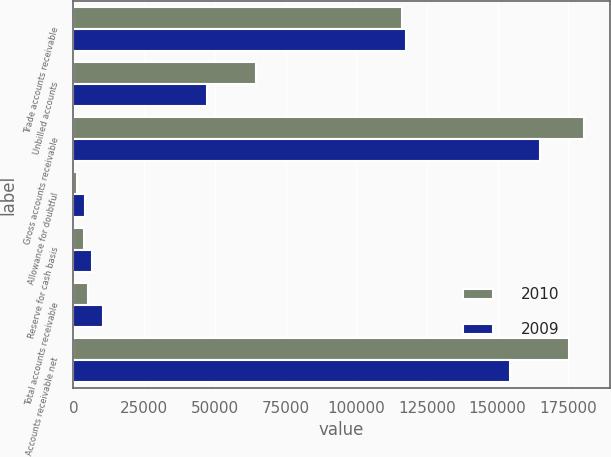Convert chart. <chart><loc_0><loc_0><loc_500><loc_500><stacked_bar_chart><ecel><fcel>Trade accounts receivable<fcel>Unbilled accounts<fcel>Gross accounts receivable<fcel>Allowance for doubtful<fcel>Reserve for cash basis<fcel>Total accounts receivable<fcel>Accounts receivable net<nl><fcel>2010<fcel>116212<fcel>64386<fcel>180598<fcel>1329<fcel>3903<fcel>5232<fcel>175366<nl><fcel>2009<fcel>117449<fcel>47399<fcel>164848<fcel>4137<fcel>6442<fcel>10579<fcel>154269<nl></chart> 